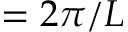Convert formula to latex. <formula><loc_0><loc_0><loc_500><loc_500>= 2 \pi / L</formula> 